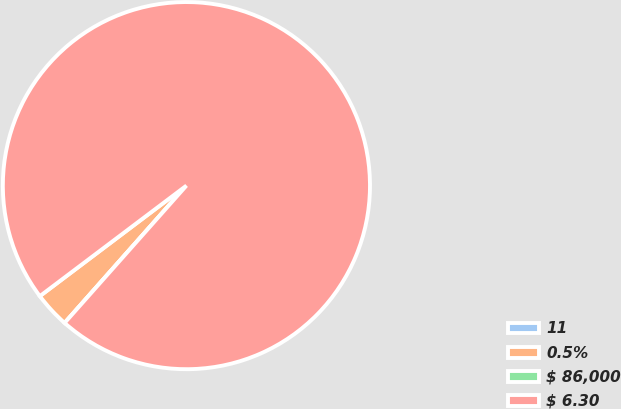<chart> <loc_0><loc_0><loc_500><loc_500><pie_chart><fcel>11<fcel>0.5%<fcel>$ 86,000<fcel>$ 6.30<nl><fcel>0.0%<fcel>3.17%<fcel>0.0%<fcel>96.83%<nl></chart> 